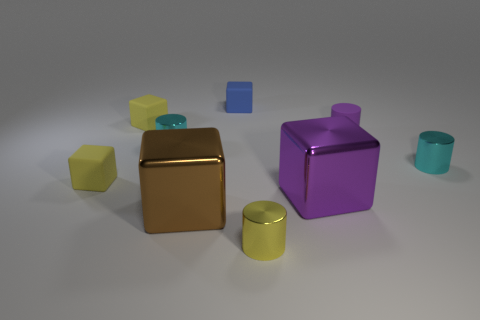Can you describe the lighting in the scene? Certainly. The lighting in the image seems to come from a diffuse source, casting soft shadows and gentle highlights on the objects. This imbues the scene with a tranquil and balanced atmosphere, showcasing the objects without harsh contrast. Does the lighting affect the colors of the objects? Indeed, the diffuse lighting subtly affects the colors, enhancing their richness and depth. It gently amplifies the glossiness of the surfaces, which reflects the light and exhibits the vibrant colors in a more profound way. 